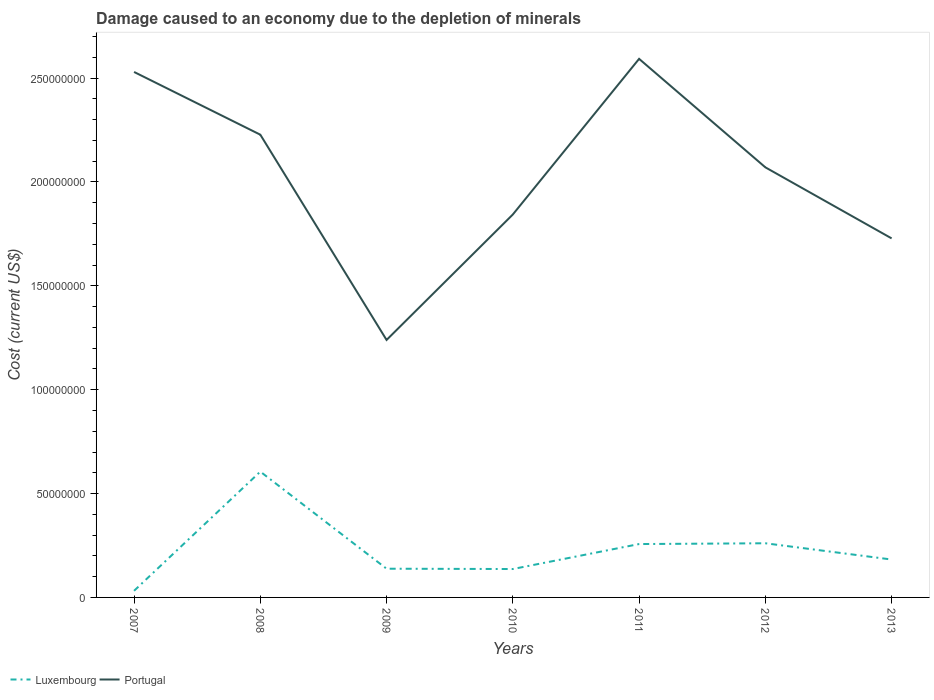Does the line corresponding to Portugal intersect with the line corresponding to Luxembourg?
Provide a succinct answer. No. Across all years, what is the maximum cost of damage caused due to the depletion of minerals in Luxembourg?
Ensure brevity in your answer.  3.19e+06. In which year was the cost of damage caused due to the depletion of minerals in Luxembourg maximum?
Provide a short and direct response. 2007. What is the total cost of damage caused due to the depletion of minerals in Luxembourg in the graph?
Your response must be concise. 3.49e+07. What is the difference between the highest and the second highest cost of damage caused due to the depletion of minerals in Portugal?
Ensure brevity in your answer.  1.35e+08. Is the cost of damage caused due to the depletion of minerals in Luxembourg strictly greater than the cost of damage caused due to the depletion of minerals in Portugal over the years?
Your answer should be compact. Yes. How many lines are there?
Provide a succinct answer. 2. How many years are there in the graph?
Provide a short and direct response. 7. Does the graph contain any zero values?
Ensure brevity in your answer.  No. Does the graph contain grids?
Keep it short and to the point. No. Where does the legend appear in the graph?
Your response must be concise. Bottom left. How are the legend labels stacked?
Offer a very short reply. Horizontal. What is the title of the graph?
Give a very brief answer. Damage caused to an economy due to the depletion of minerals. What is the label or title of the X-axis?
Provide a short and direct response. Years. What is the label or title of the Y-axis?
Ensure brevity in your answer.  Cost (current US$). What is the Cost (current US$) of Luxembourg in 2007?
Offer a terse response. 3.19e+06. What is the Cost (current US$) in Portugal in 2007?
Give a very brief answer. 2.53e+08. What is the Cost (current US$) in Luxembourg in 2008?
Your response must be concise. 6.06e+07. What is the Cost (current US$) in Portugal in 2008?
Provide a short and direct response. 2.23e+08. What is the Cost (current US$) in Luxembourg in 2009?
Offer a very short reply. 1.38e+07. What is the Cost (current US$) of Portugal in 2009?
Your answer should be compact. 1.24e+08. What is the Cost (current US$) in Luxembourg in 2010?
Provide a succinct answer. 1.37e+07. What is the Cost (current US$) in Portugal in 2010?
Give a very brief answer. 1.84e+08. What is the Cost (current US$) of Luxembourg in 2011?
Provide a succinct answer. 2.57e+07. What is the Cost (current US$) in Portugal in 2011?
Give a very brief answer. 2.59e+08. What is the Cost (current US$) in Luxembourg in 2012?
Keep it short and to the point. 2.61e+07. What is the Cost (current US$) of Portugal in 2012?
Offer a terse response. 2.07e+08. What is the Cost (current US$) of Luxembourg in 2013?
Give a very brief answer. 1.82e+07. What is the Cost (current US$) in Portugal in 2013?
Provide a succinct answer. 1.73e+08. Across all years, what is the maximum Cost (current US$) of Luxembourg?
Ensure brevity in your answer.  6.06e+07. Across all years, what is the maximum Cost (current US$) of Portugal?
Keep it short and to the point. 2.59e+08. Across all years, what is the minimum Cost (current US$) of Luxembourg?
Offer a terse response. 3.19e+06. Across all years, what is the minimum Cost (current US$) of Portugal?
Offer a terse response. 1.24e+08. What is the total Cost (current US$) in Luxembourg in the graph?
Offer a terse response. 1.61e+08. What is the total Cost (current US$) in Portugal in the graph?
Offer a very short reply. 1.42e+09. What is the difference between the Cost (current US$) in Luxembourg in 2007 and that in 2008?
Your answer should be compact. -5.74e+07. What is the difference between the Cost (current US$) in Portugal in 2007 and that in 2008?
Provide a succinct answer. 3.02e+07. What is the difference between the Cost (current US$) of Luxembourg in 2007 and that in 2009?
Offer a terse response. -1.06e+07. What is the difference between the Cost (current US$) of Portugal in 2007 and that in 2009?
Offer a very short reply. 1.29e+08. What is the difference between the Cost (current US$) of Luxembourg in 2007 and that in 2010?
Your answer should be compact. -1.05e+07. What is the difference between the Cost (current US$) of Portugal in 2007 and that in 2010?
Provide a short and direct response. 6.86e+07. What is the difference between the Cost (current US$) of Luxembourg in 2007 and that in 2011?
Your answer should be very brief. -2.25e+07. What is the difference between the Cost (current US$) in Portugal in 2007 and that in 2011?
Your answer should be compact. -6.31e+06. What is the difference between the Cost (current US$) in Luxembourg in 2007 and that in 2012?
Offer a very short reply. -2.29e+07. What is the difference between the Cost (current US$) in Portugal in 2007 and that in 2012?
Offer a terse response. 4.59e+07. What is the difference between the Cost (current US$) in Luxembourg in 2007 and that in 2013?
Ensure brevity in your answer.  -1.51e+07. What is the difference between the Cost (current US$) of Portugal in 2007 and that in 2013?
Ensure brevity in your answer.  8.01e+07. What is the difference between the Cost (current US$) in Luxembourg in 2008 and that in 2009?
Make the answer very short. 4.67e+07. What is the difference between the Cost (current US$) in Portugal in 2008 and that in 2009?
Make the answer very short. 9.88e+07. What is the difference between the Cost (current US$) of Luxembourg in 2008 and that in 2010?
Offer a terse response. 4.69e+07. What is the difference between the Cost (current US$) of Portugal in 2008 and that in 2010?
Offer a terse response. 3.84e+07. What is the difference between the Cost (current US$) of Luxembourg in 2008 and that in 2011?
Your answer should be very brief. 3.49e+07. What is the difference between the Cost (current US$) in Portugal in 2008 and that in 2011?
Offer a terse response. -3.65e+07. What is the difference between the Cost (current US$) in Luxembourg in 2008 and that in 2012?
Keep it short and to the point. 3.45e+07. What is the difference between the Cost (current US$) in Portugal in 2008 and that in 2012?
Offer a very short reply. 1.57e+07. What is the difference between the Cost (current US$) of Luxembourg in 2008 and that in 2013?
Provide a short and direct response. 4.23e+07. What is the difference between the Cost (current US$) in Portugal in 2008 and that in 2013?
Your answer should be very brief. 4.99e+07. What is the difference between the Cost (current US$) in Luxembourg in 2009 and that in 2010?
Make the answer very short. 1.50e+05. What is the difference between the Cost (current US$) in Portugal in 2009 and that in 2010?
Ensure brevity in your answer.  -6.04e+07. What is the difference between the Cost (current US$) in Luxembourg in 2009 and that in 2011?
Your response must be concise. -1.19e+07. What is the difference between the Cost (current US$) of Portugal in 2009 and that in 2011?
Ensure brevity in your answer.  -1.35e+08. What is the difference between the Cost (current US$) of Luxembourg in 2009 and that in 2012?
Give a very brief answer. -1.22e+07. What is the difference between the Cost (current US$) in Portugal in 2009 and that in 2012?
Ensure brevity in your answer.  -8.31e+07. What is the difference between the Cost (current US$) of Luxembourg in 2009 and that in 2013?
Keep it short and to the point. -4.42e+06. What is the difference between the Cost (current US$) in Portugal in 2009 and that in 2013?
Your answer should be very brief. -4.89e+07. What is the difference between the Cost (current US$) in Luxembourg in 2010 and that in 2011?
Give a very brief answer. -1.20e+07. What is the difference between the Cost (current US$) in Portugal in 2010 and that in 2011?
Make the answer very short. -7.49e+07. What is the difference between the Cost (current US$) in Luxembourg in 2010 and that in 2012?
Your answer should be compact. -1.24e+07. What is the difference between the Cost (current US$) of Portugal in 2010 and that in 2012?
Keep it short and to the point. -2.27e+07. What is the difference between the Cost (current US$) of Luxembourg in 2010 and that in 2013?
Your answer should be compact. -4.57e+06. What is the difference between the Cost (current US$) in Portugal in 2010 and that in 2013?
Offer a very short reply. 1.15e+07. What is the difference between the Cost (current US$) of Luxembourg in 2011 and that in 2012?
Your response must be concise. -3.77e+05. What is the difference between the Cost (current US$) in Portugal in 2011 and that in 2012?
Offer a very short reply. 5.22e+07. What is the difference between the Cost (current US$) in Luxembourg in 2011 and that in 2013?
Keep it short and to the point. 7.45e+06. What is the difference between the Cost (current US$) in Portugal in 2011 and that in 2013?
Your response must be concise. 8.64e+07. What is the difference between the Cost (current US$) of Luxembourg in 2012 and that in 2013?
Your answer should be compact. 7.83e+06. What is the difference between the Cost (current US$) of Portugal in 2012 and that in 2013?
Give a very brief answer. 3.42e+07. What is the difference between the Cost (current US$) of Luxembourg in 2007 and the Cost (current US$) of Portugal in 2008?
Offer a terse response. -2.20e+08. What is the difference between the Cost (current US$) in Luxembourg in 2007 and the Cost (current US$) in Portugal in 2009?
Provide a succinct answer. -1.21e+08. What is the difference between the Cost (current US$) of Luxembourg in 2007 and the Cost (current US$) of Portugal in 2010?
Make the answer very short. -1.81e+08. What is the difference between the Cost (current US$) in Luxembourg in 2007 and the Cost (current US$) in Portugal in 2011?
Your answer should be very brief. -2.56e+08. What is the difference between the Cost (current US$) of Luxembourg in 2007 and the Cost (current US$) of Portugal in 2012?
Provide a succinct answer. -2.04e+08. What is the difference between the Cost (current US$) in Luxembourg in 2007 and the Cost (current US$) in Portugal in 2013?
Your answer should be very brief. -1.70e+08. What is the difference between the Cost (current US$) in Luxembourg in 2008 and the Cost (current US$) in Portugal in 2009?
Offer a very short reply. -6.34e+07. What is the difference between the Cost (current US$) of Luxembourg in 2008 and the Cost (current US$) of Portugal in 2010?
Keep it short and to the point. -1.24e+08. What is the difference between the Cost (current US$) of Luxembourg in 2008 and the Cost (current US$) of Portugal in 2011?
Make the answer very short. -1.99e+08. What is the difference between the Cost (current US$) in Luxembourg in 2008 and the Cost (current US$) in Portugal in 2012?
Give a very brief answer. -1.46e+08. What is the difference between the Cost (current US$) of Luxembourg in 2008 and the Cost (current US$) of Portugal in 2013?
Give a very brief answer. -1.12e+08. What is the difference between the Cost (current US$) of Luxembourg in 2009 and the Cost (current US$) of Portugal in 2010?
Keep it short and to the point. -1.71e+08. What is the difference between the Cost (current US$) of Luxembourg in 2009 and the Cost (current US$) of Portugal in 2011?
Make the answer very short. -2.45e+08. What is the difference between the Cost (current US$) in Luxembourg in 2009 and the Cost (current US$) in Portugal in 2012?
Offer a very short reply. -1.93e+08. What is the difference between the Cost (current US$) in Luxembourg in 2009 and the Cost (current US$) in Portugal in 2013?
Ensure brevity in your answer.  -1.59e+08. What is the difference between the Cost (current US$) in Luxembourg in 2010 and the Cost (current US$) in Portugal in 2011?
Make the answer very short. -2.46e+08. What is the difference between the Cost (current US$) in Luxembourg in 2010 and the Cost (current US$) in Portugal in 2012?
Your response must be concise. -1.93e+08. What is the difference between the Cost (current US$) in Luxembourg in 2010 and the Cost (current US$) in Portugal in 2013?
Your answer should be compact. -1.59e+08. What is the difference between the Cost (current US$) in Luxembourg in 2011 and the Cost (current US$) in Portugal in 2012?
Provide a short and direct response. -1.81e+08. What is the difference between the Cost (current US$) of Luxembourg in 2011 and the Cost (current US$) of Portugal in 2013?
Ensure brevity in your answer.  -1.47e+08. What is the difference between the Cost (current US$) in Luxembourg in 2012 and the Cost (current US$) in Portugal in 2013?
Your answer should be compact. -1.47e+08. What is the average Cost (current US$) in Luxembourg per year?
Offer a terse response. 2.30e+07. What is the average Cost (current US$) of Portugal per year?
Offer a terse response. 2.03e+08. In the year 2007, what is the difference between the Cost (current US$) in Luxembourg and Cost (current US$) in Portugal?
Offer a terse response. -2.50e+08. In the year 2008, what is the difference between the Cost (current US$) in Luxembourg and Cost (current US$) in Portugal?
Make the answer very short. -1.62e+08. In the year 2009, what is the difference between the Cost (current US$) of Luxembourg and Cost (current US$) of Portugal?
Your answer should be very brief. -1.10e+08. In the year 2010, what is the difference between the Cost (current US$) in Luxembourg and Cost (current US$) in Portugal?
Offer a very short reply. -1.71e+08. In the year 2011, what is the difference between the Cost (current US$) in Luxembourg and Cost (current US$) in Portugal?
Provide a short and direct response. -2.34e+08. In the year 2012, what is the difference between the Cost (current US$) in Luxembourg and Cost (current US$) in Portugal?
Offer a terse response. -1.81e+08. In the year 2013, what is the difference between the Cost (current US$) of Luxembourg and Cost (current US$) of Portugal?
Keep it short and to the point. -1.55e+08. What is the ratio of the Cost (current US$) of Luxembourg in 2007 to that in 2008?
Provide a short and direct response. 0.05. What is the ratio of the Cost (current US$) in Portugal in 2007 to that in 2008?
Ensure brevity in your answer.  1.14. What is the ratio of the Cost (current US$) in Luxembourg in 2007 to that in 2009?
Your answer should be very brief. 0.23. What is the ratio of the Cost (current US$) in Portugal in 2007 to that in 2009?
Ensure brevity in your answer.  2.04. What is the ratio of the Cost (current US$) in Luxembourg in 2007 to that in 2010?
Offer a very short reply. 0.23. What is the ratio of the Cost (current US$) of Portugal in 2007 to that in 2010?
Keep it short and to the point. 1.37. What is the ratio of the Cost (current US$) of Luxembourg in 2007 to that in 2011?
Make the answer very short. 0.12. What is the ratio of the Cost (current US$) of Portugal in 2007 to that in 2011?
Provide a succinct answer. 0.98. What is the ratio of the Cost (current US$) in Luxembourg in 2007 to that in 2012?
Provide a short and direct response. 0.12. What is the ratio of the Cost (current US$) in Portugal in 2007 to that in 2012?
Make the answer very short. 1.22. What is the ratio of the Cost (current US$) in Luxembourg in 2007 to that in 2013?
Your answer should be compact. 0.17. What is the ratio of the Cost (current US$) in Portugal in 2007 to that in 2013?
Provide a succinct answer. 1.46. What is the ratio of the Cost (current US$) of Luxembourg in 2008 to that in 2009?
Keep it short and to the point. 4.38. What is the ratio of the Cost (current US$) in Portugal in 2008 to that in 2009?
Your answer should be compact. 1.8. What is the ratio of the Cost (current US$) in Luxembourg in 2008 to that in 2010?
Make the answer very short. 4.43. What is the ratio of the Cost (current US$) in Portugal in 2008 to that in 2010?
Offer a terse response. 1.21. What is the ratio of the Cost (current US$) of Luxembourg in 2008 to that in 2011?
Offer a terse response. 2.36. What is the ratio of the Cost (current US$) of Portugal in 2008 to that in 2011?
Your answer should be very brief. 0.86. What is the ratio of the Cost (current US$) in Luxembourg in 2008 to that in 2012?
Provide a short and direct response. 2.32. What is the ratio of the Cost (current US$) of Portugal in 2008 to that in 2012?
Your response must be concise. 1.08. What is the ratio of the Cost (current US$) in Luxembourg in 2008 to that in 2013?
Your response must be concise. 3.32. What is the ratio of the Cost (current US$) of Portugal in 2008 to that in 2013?
Give a very brief answer. 1.29. What is the ratio of the Cost (current US$) in Luxembourg in 2009 to that in 2010?
Your answer should be very brief. 1.01. What is the ratio of the Cost (current US$) in Portugal in 2009 to that in 2010?
Provide a short and direct response. 0.67. What is the ratio of the Cost (current US$) of Luxembourg in 2009 to that in 2011?
Make the answer very short. 0.54. What is the ratio of the Cost (current US$) in Portugal in 2009 to that in 2011?
Offer a terse response. 0.48. What is the ratio of the Cost (current US$) of Luxembourg in 2009 to that in 2012?
Your answer should be very brief. 0.53. What is the ratio of the Cost (current US$) of Portugal in 2009 to that in 2012?
Ensure brevity in your answer.  0.6. What is the ratio of the Cost (current US$) of Luxembourg in 2009 to that in 2013?
Your answer should be very brief. 0.76. What is the ratio of the Cost (current US$) in Portugal in 2009 to that in 2013?
Your answer should be compact. 0.72. What is the ratio of the Cost (current US$) of Luxembourg in 2010 to that in 2011?
Your answer should be very brief. 0.53. What is the ratio of the Cost (current US$) in Portugal in 2010 to that in 2011?
Provide a succinct answer. 0.71. What is the ratio of the Cost (current US$) in Luxembourg in 2010 to that in 2012?
Offer a terse response. 0.52. What is the ratio of the Cost (current US$) in Portugal in 2010 to that in 2012?
Give a very brief answer. 0.89. What is the ratio of the Cost (current US$) of Luxembourg in 2010 to that in 2013?
Ensure brevity in your answer.  0.75. What is the ratio of the Cost (current US$) in Portugal in 2010 to that in 2013?
Make the answer very short. 1.07. What is the ratio of the Cost (current US$) in Luxembourg in 2011 to that in 2012?
Give a very brief answer. 0.99. What is the ratio of the Cost (current US$) of Portugal in 2011 to that in 2012?
Provide a short and direct response. 1.25. What is the ratio of the Cost (current US$) in Luxembourg in 2011 to that in 2013?
Ensure brevity in your answer.  1.41. What is the ratio of the Cost (current US$) in Portugal in 2011 to that in 2013?
Your response must be concise. 1.5. What is the ratio of the Cost (current US$) in Luxembourg in 2012 to that in 2013?
Your answer should be compact. 1.43. What is the ratio of the Cost (current US$) in Portugal in 2012 to that in 2013?
Provide a short and direct response. 1.2. What is the difference between the highest and the second highest Cost (current US$) in Luxembourg?
Your answer should be very brief. 3.45e+07. What is the difference between the highest and the second highest Cost (current US$) in Portugal?
Keep it short and to the point. 6.31e+06. What is the difference between the highest and the lowest Cost (current US$) in Luxembourg?
Your response must be concise. 5.74e+07. What is the difference between the highest and the lowest Cost (current US$) in Portugal?
Give a very brief answer. 1.35e+08. 